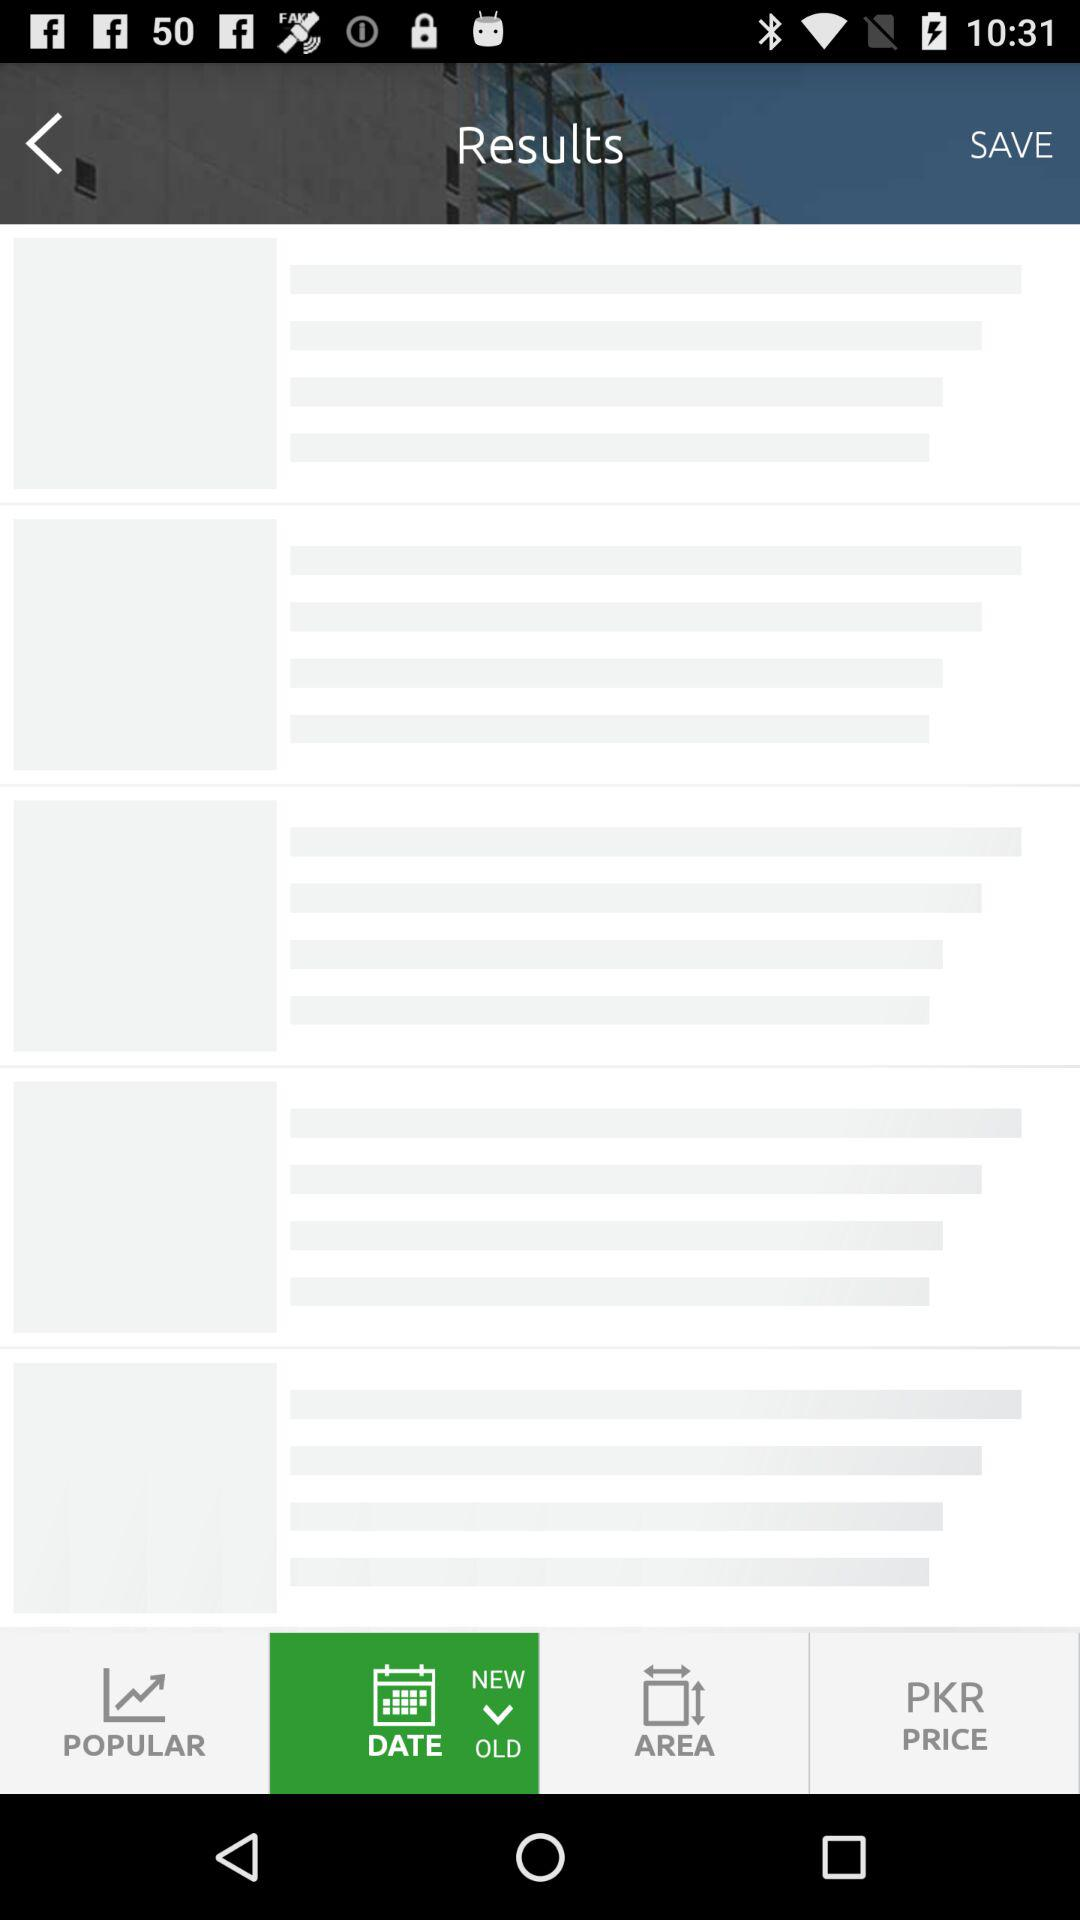What is the full address of the bungalow? The full address of the bungalow is Block G, DHA Phase 6, DHA Defence. 